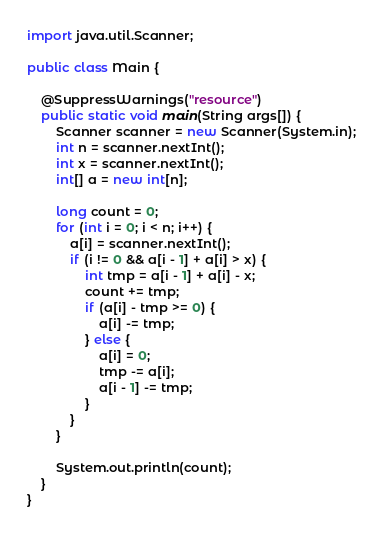Convert code to text. <code><loc_0><loc_0><loc_500><loc_500><_Java_>import java.util.Scanner;

public class Main {

	@SuppressWarnings("resource")
	public static void main(String args[]) {
		Scanner scanner = new Scanner(System.in);
		int n = scanner.nextInt();
		int x = scanner.nextInt();
		int[] a = new int[n];

		long count = 0;
		for (int i = 0; i < n; i++) {
			a[i] = scanner.nextInt();
			if (i != 0 && a[i - 1] + a[i] > x) {
				int tmp = a[i - 1] + a[i] - x;
				count += tmp;
				if (a[i] - tmp >= 0) {
					a[i] -= tmp;
				} else {
					a[i] = 0;
					tmp -= a[i];
					a[i - 1] -= tmp;
				}
			}
		}

		System.out.println(count);
	}
}</code> 